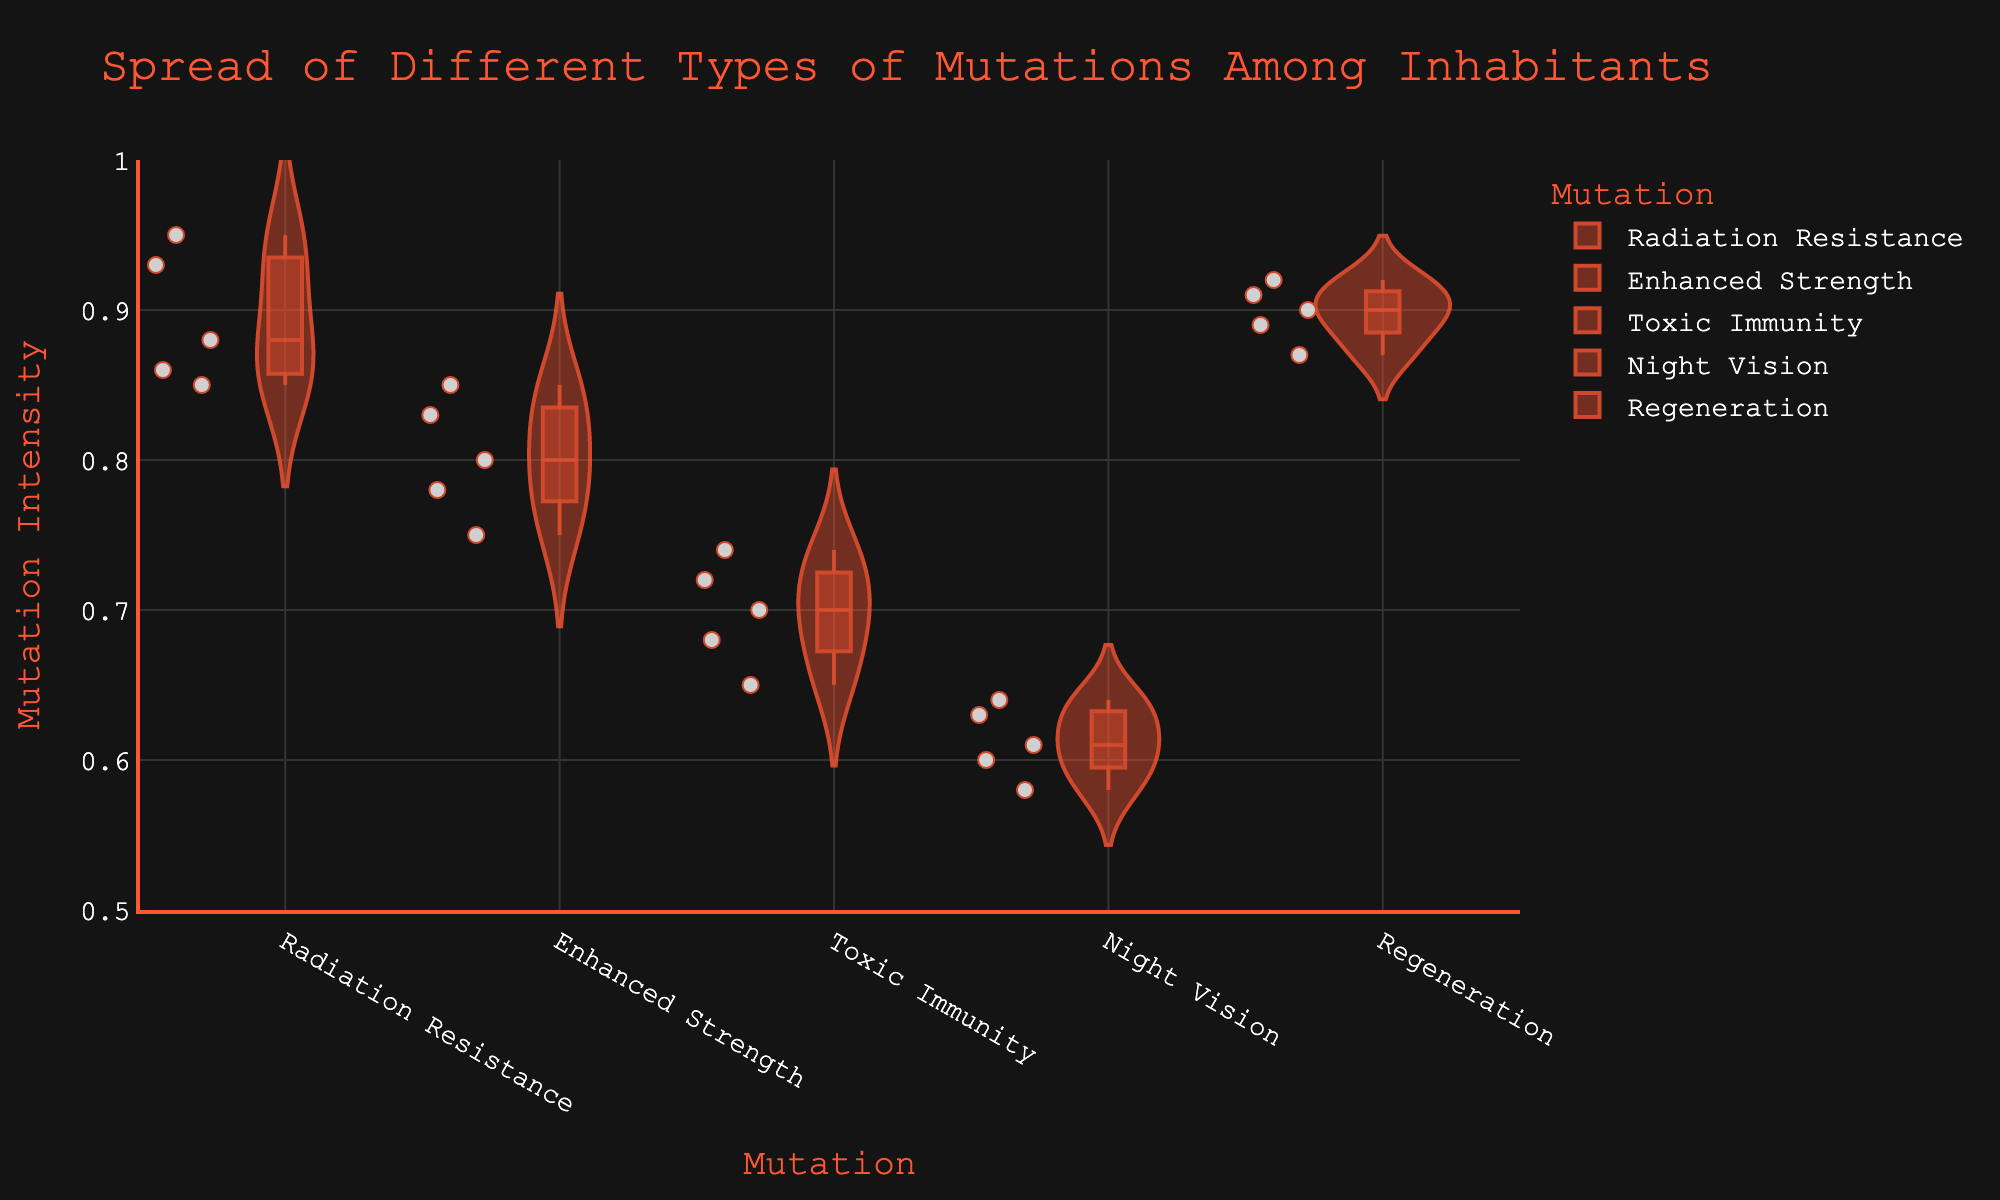What is the title of the figure? The title of the figure is displayed at the top of the chart. It provides a clear and concise summary of what the chart represents.
Answer: Spread of Different Types of Mutations Among Inhabitants Which mutation has the highest median value? To find the highest median value, we need to look at the box plot in each violin plot, which represents the median value. The regeneration mutation has the highest median value.
Answer: Regeneration Which mutation has the lowest variation in Mutation Intensity? To determine the mutation with the lowest variation, look for the violin plot that is the narrowest. Night vision has the least variation, indicating that the values are more consistent among inhabitants.
Answer: Night Vision How many types of mutations are shown in the chart? By counting the different categories on the x-axis, we can determine the number of mutation types shown. There are five categories.
Answer: Five What is the range of values for the Enhanced Strength mutation? The range of values can be determined by looking at the highest and lowest points within the Enhanced Strength violin plot. The range is from 0.75 to 0.85.
Answer: 0.75 to 0.85 Which mutation has the widest spread in Mutation Intensity values? The widest spread can be identified by finding the widest range in the violin plots. Radiation Resistance has the widest spread of values from approximately 0.85 to 0.95.
Answer: Radiation Resistance Which two mutations have the closest median values? We need to compare the median lines of each violin plot to find the two closest median values. Radiation Resistance and Regeneration have very close median values.
Answer: Radiation Resistance and Regeneration What is the average mutation intensity for Radiation Resistance? To find the average, sum all the mutation values for Radiation Resistance and divide by the number of data points: (0.86 + 0.93 + 0.88 + 0.85 + 0.95)/5 = (4.47)/5 = 0.894
Answer: 0.894 Which mutation shows the most outliers (individual points outside of the box in the violin plot)? To determine this, count the number of individual points outside of the box for each violin plot. Toxic Immunity has the most outliers.
Answer: Toxic Immunity How does the variation in Mutation Intensity for Night Vision compare to Regeneration? To compare the variation, look at the spread of the violin plots for both mutations. Night Vision has a narrower spread compared to Regeneration, indicating less variation in values.
Answer: Night Vision has less variation 